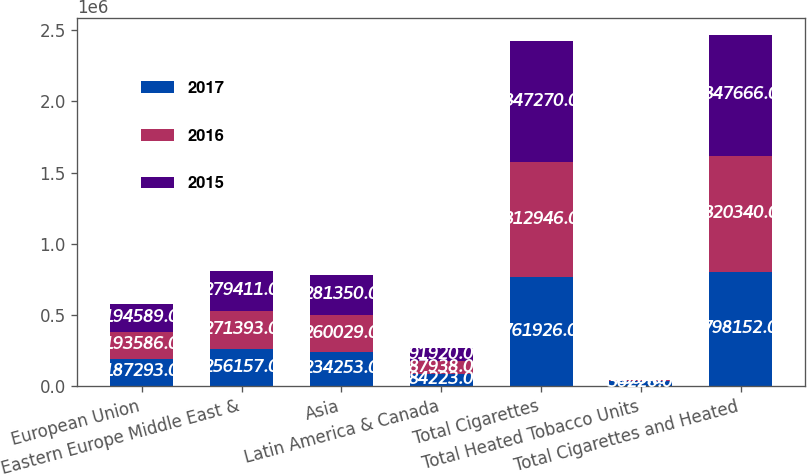<chart> <loc_0><loc_0><loc_500><loc_500><stacked_bar_chart><ecel><fcel>European Union<fcel>Eastern Europe Middle East &<fcel>Asia<fcel>Latin America & Canada<fcel>Total Cigarettes<fcel>Total Heated Tobacco Units<fcel>Total Cigarettes and Heated<nl><fcel>2017<fcel>187293<fcel>256157<fcel>234253<fcel>84223<fcel>761926<fcel>36226<fcel>798152<nl><fcel>2016<fcel>193586<fcel>271393<fcel>260029<fcel>87938<fcel>812946<fcel>7394<fcel>820340<nl><fcel>2015<fcel>194589<fcel>279411<fcel>281350<fcel>91920<fcel>847270<fcel>396<fcel>847666<nl></chart> 